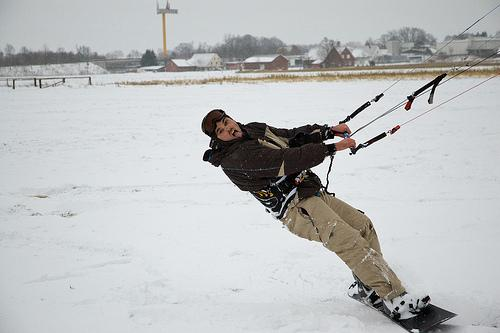List down the types of winter apparel seen in the focal person of the image. Brown winter jacket, beige snow pants, protective eyewear (goggles), and black snowboard. Mention the prime elements that make up the winter surroundings of the subject. Snowy fields, a fence in the distance, red and tan houses, a barn, and pine trees create the perfect winter ambiance for snowboarding. Provide a brief description of the most prominent person in the image. A man wearing a brown jacket and beige pants, leaning on his black snowboard, has his tongue out and goggles on his forehead. Narrate the sporting activity performed by the person in the image. The man is skillfully taking on the snowy incline with his black snowboard as he leans in preparation for another thrilling ride. What is the primary action performed by the person in the image? The man is leaning on his black snowboard with his tongue out, ready to snowboard down the slope. Write a brief story describing the image. In a serene, snow-covered field, a playful snowboarder leans on his black snowboard, sticking his tongue out. Dressed in a warm brown jacket and beige pants, he's ready for some winter fun. Describe the sequence of events leading up to the man's action in the image. In a winter wonderland, the man gazed around and wore his warm flurry gears. He held his snowboard close and positioned himself for an adventurous ride, his tongue out playfully expressing his excitement. Explain the apparel and appearance of the main person in the image. The man in the image is wearing a brown winter coat with beige snow pants and has goggles on his forehead, ready for a snowboarding adventure. Mention the most noticeable scene in the background of the image. A beautiful snowy landscape with a fence, red and tan houses, a barn, and pine trees in the distance. What is the fun element being showcased by the man in the image? The man is sticking his tongue out, depicting a playful and carefree attitude as he prepares to snowboard. 